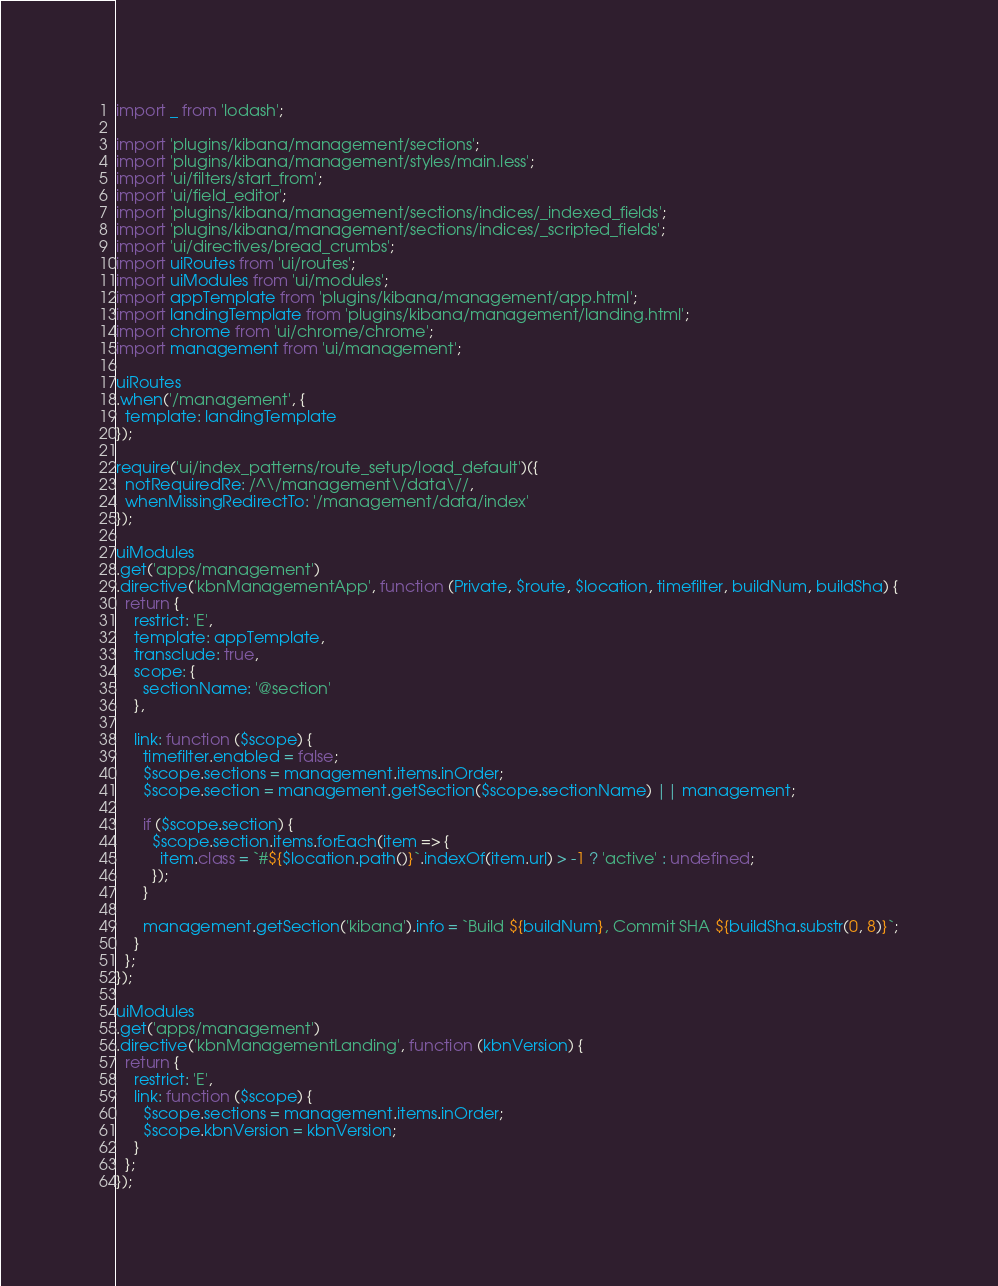<code> <loc_0><loc_0><loc_500><loc_500><_JavaScript_>import _ from 'lodash';

import 'plugins/kibana/management/sections';
import 'plugins/kibana/management/styles/main.less';
import 'ui/filters/start_from';
import 'ui/field_editor';
import 'plugins/kibana/management/sections/indices/_indexed_fields';
import 'plugins/kibana/management/sections/indices/_scripted_fields';
import 'ui/directives/bread_crumbs';
import uiRoutes from 'ui/routes';
import uiModules from 'ui/modules';
import appTemplate from 'plugins/kibana/management/app.html';
import landingTemplate from 'plugins/kibana/management/landing.html';
import chrome from 'ui/chrome/chrome';
import management from 'ui/management';

uiRoutes
.when('/management', {
  template: landingTemplate
});

require('ui/index_patterns/route_setup/load_default')({
  notRequiredRe: /^\/management\/data\//,
  whenMissingRedirectTo: '/management/data/index'
});

uiModules
.get('apps/management')
.directive('kbnManagementApp', function (Private, $route, $location, timefilter, buildNum, buildSha) {
  return {
    restrict: 'E',
    template: appTemplate,
    transclude: true,
    scope: {
      sectionName: '@section'
    },

    link: function ($scope) {
      timefilter.enabled = false;
      $scope.sections = management.items.inOrder;
      $scope.section = management.getSection($scope.sectionName) || management;

      if ($scope.section) {
        $scope.section.items.forEach(item => {
          item.class = `#${$location.path()}`.indexOf(item.url) > -1 ? 'active' : undefined;
        });
      }

      management.getSection('kibana').info = `Build ${buildNum}, Commit SHA ${buildSha.substr(0, 8)}`;
    }
  };
});

uiModules
.get('apps/management')
.directive('kbnManagementLanding', function (kbnVersion) {
  return {
    restrict: 'E',
    link: function ($scope) {
      $scope.sections = management.items.inOrder;
      $scope.kbnVersion = kbnVersion;
    }
  };
});
</code> 